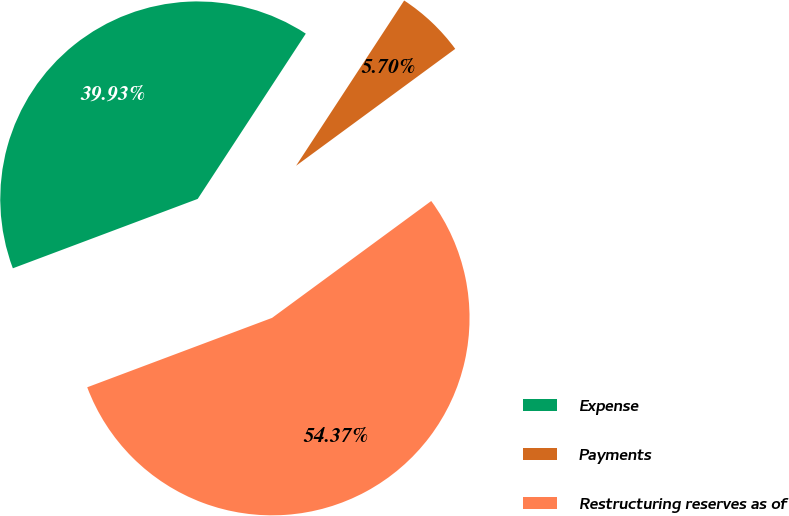<chart> <loc_0><loc_0><loc_500><loc_500><pie_chart><fcel>Expense<fcel>Payments<fcel>Restructuring reserves as of<nl><fcel>39.93%<fcel>5.7%<fcel>54.36%<nl></chart> 